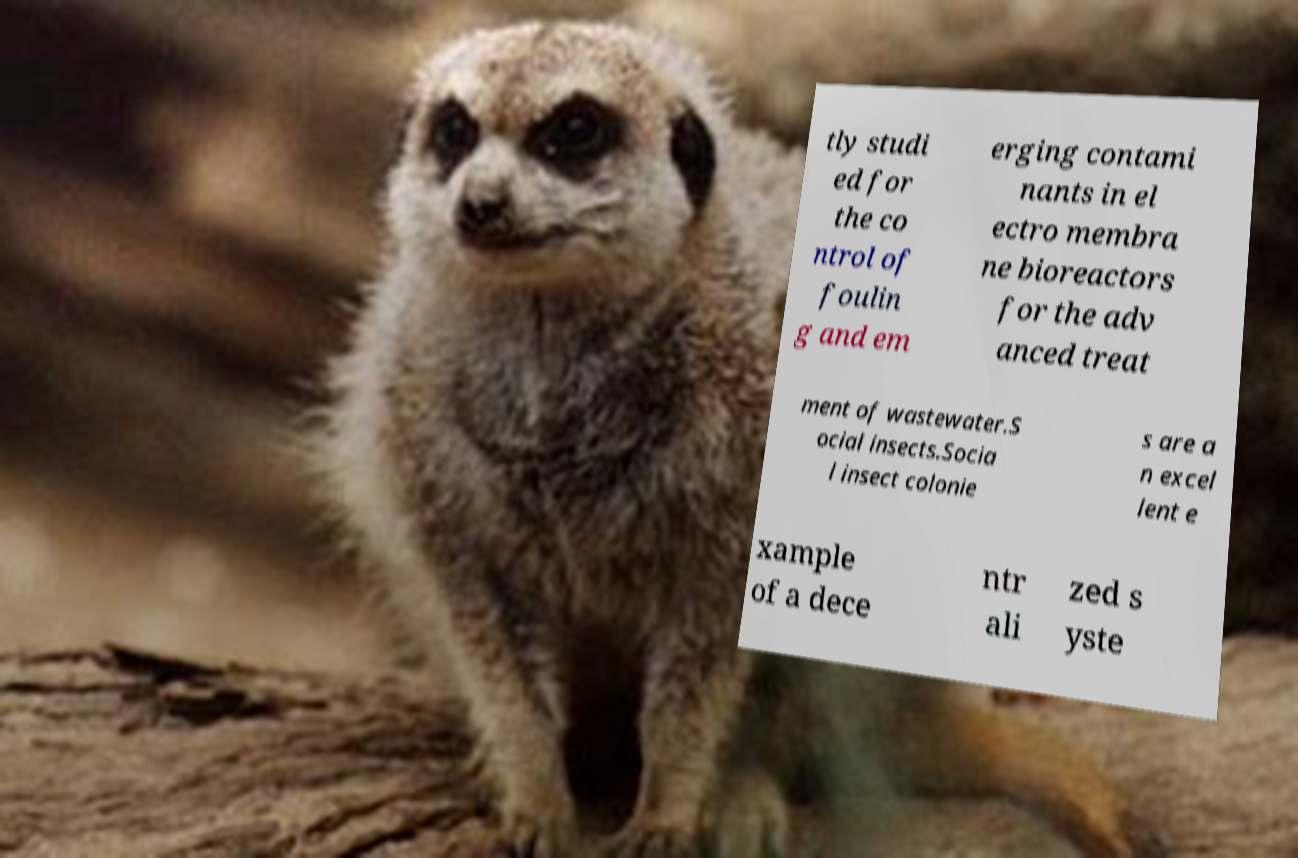Could you extract and type out the text from this image? tly studi ed for the co ntrol of foulin g and em erging contami nants in el ectro membra ne bioreactors for the adv anced treat ment of wastewater.S ocial insects.Socia l insect colonie s are a n excel lent e xample of a dece ntr ali zed s yste 